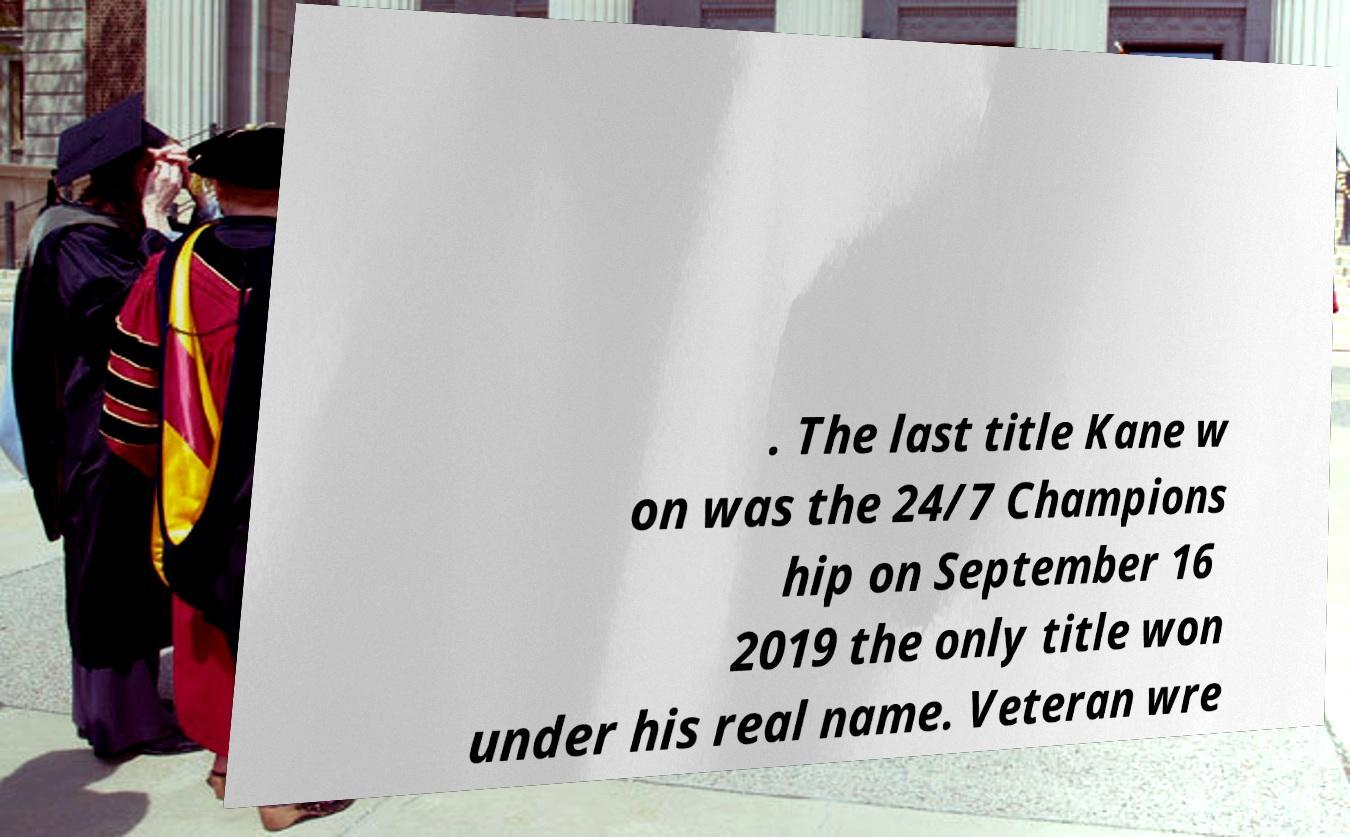Please read and relay the text visible in this image. What does it say? . The last title Kane w on was the 24/7 Champions hip on September 16 2019 the only title won under his real name. Veteran wre 